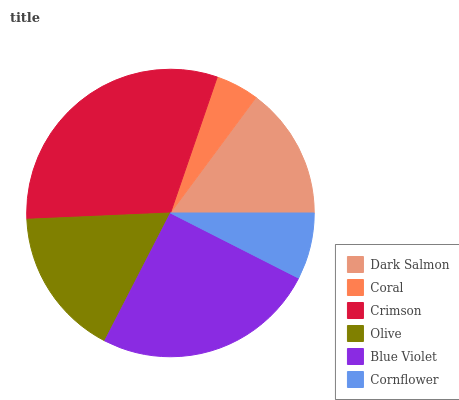Is Coral the minimum?
Answer yes or no. Yes. Is Crimson the maximum?
Answer yes or no. Yes. Is Crimson the minimum?
Answer yes or no. No. Is Coral the maximum?
Answer yes or no. No. Is Crimson greater than Coral?
Answer yes or no. Yes. Is Coral less than Crimson?
Answer yes or no. Yes. Is Coral greater than Crimson?
Answer yes or no. No. Is Crimson less than Coral?
Answer yes or no. No. Is Olive the high median?
Answer yes or no. Yes. Is Dark Salmon the low median?
Answer yes or no. Yes. Is Coral the high median?
Answer yes or no. No. Is Cornflower the low median?
Answer yes or no. No. 